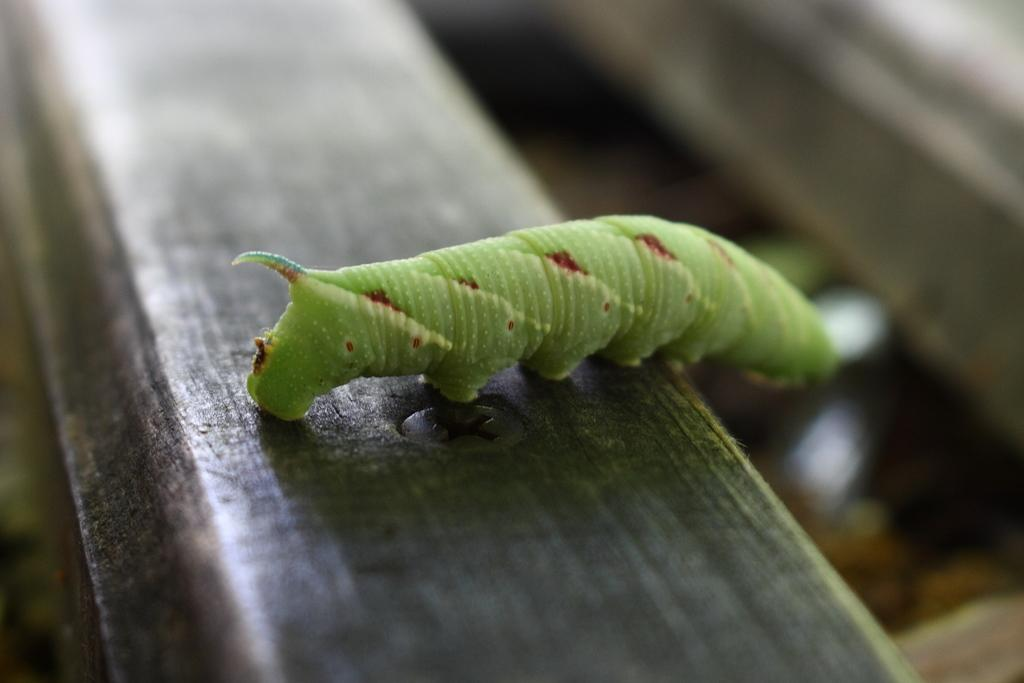What type of creature is present in the image? There is an insect in the image. What is the insect sitting on? The insect is on a wooden object. Can you describe the background of the image? The background of the image is blurred. What type of liquid can be seen dripping from the insect's wings in the image? There is no liquid dripping from the insect's wings in the image. How many birds are visible in the image? There are no birds present in the image. 